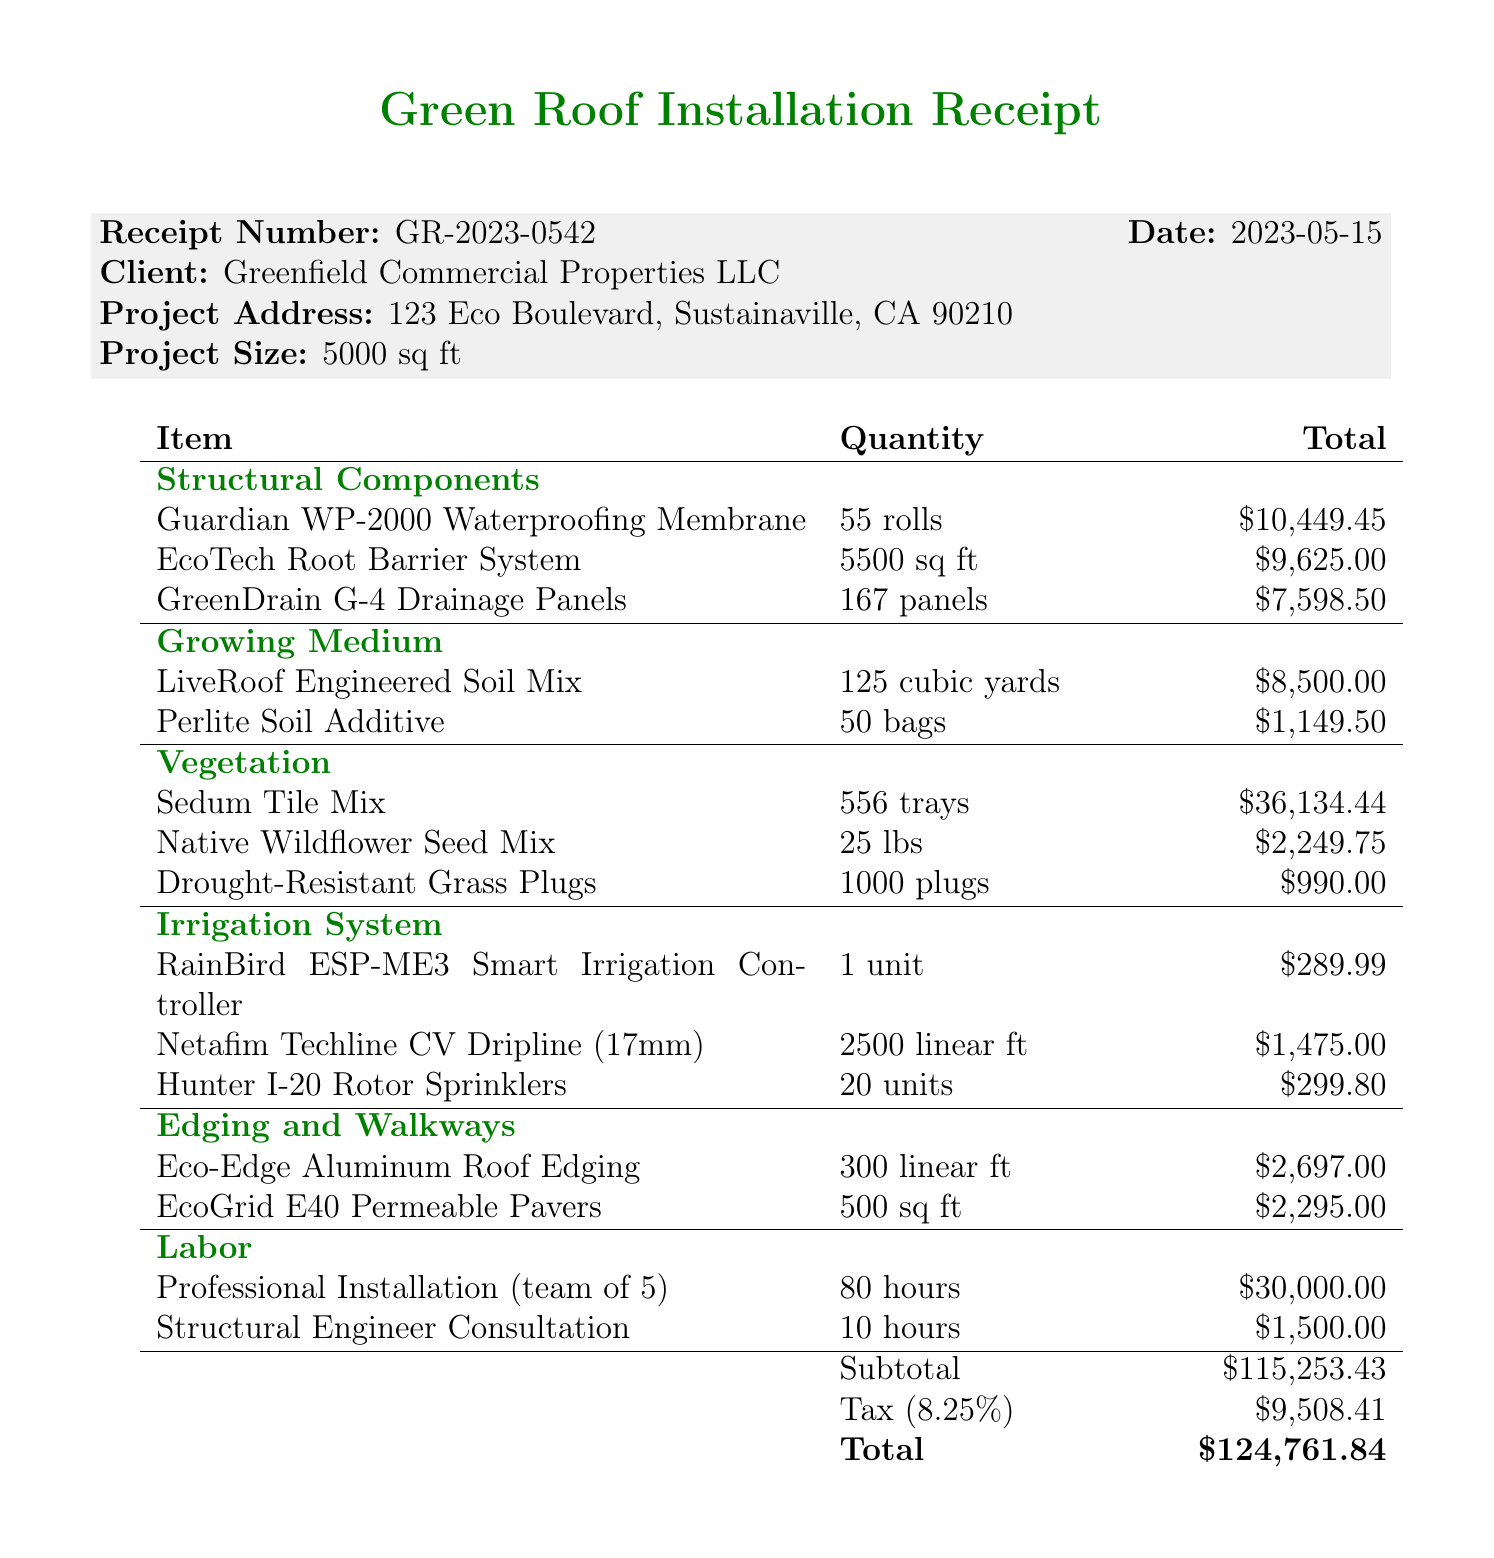What is the receipt number? The receipt number is mentioned near the top of the document as GR-2023-0542.
Answer: GR-2023-0542 What is the date of the receipt? The date is provided along with the receipt number and is recorded as 2023-05-15.
Answer: 2023-05-15 How many cubic yards of LiveRoof Engineered Soil Mix were ordered? The quantity of LiveRoof Engineered Soil Mix is stated in the Growing Medium section as 125 cubic yards.
Answer: 125 cubic yards What is the total cost for the Sedum Tile Mix? The total is found under the Vegetation category, listed as 36,134.44.
Answer: 36,134.44 What is the total amount after tax? The total amount is specified at the end of the document as 124,761.84, which includes tax.
Answer: 124,761.84 What warranty is provided for waterproofing and drainage components? The warranty details are mentioned in the notes section as a 10-year manufacturer warranty.
Answer: 10-year manufacturer warranty How many hours of professional installation were charged? The quantity of hours for professional installation is clearly listed as 80 hours in the Labor section.
Answer: 80 hours What is the estimated reduction in carbon footprint per year? This figure is noted in the notes section as 5.5 metric tons CO2e per year.
Answer: 5.5 metric tons CO2e per year What is the tax rate applied to the subtotal? The tax rate is indicated in the document as 8.25%.
Answer: 8.25% 